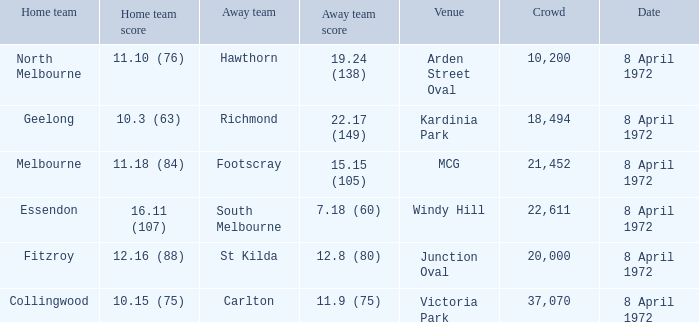Which Venue has a Home team of geelong? Kardinia Park. 